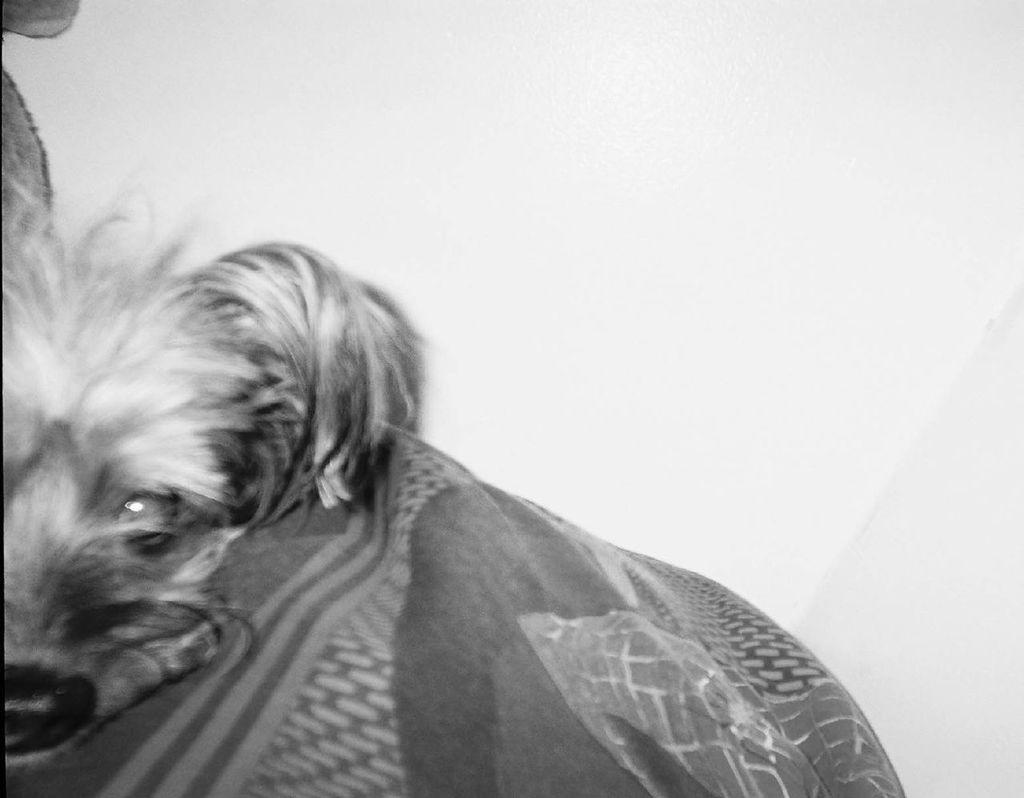What animal is present in the image? There is a dog in the picture. How is the dog positioned or dressed in the image? The dog is wrapped in a cloth. What color is the background of the image? The background of the image is white. Can you see any snakes slithering in the harbor in the image? There is no harbor or snake present in the image; it features a dog wrapped in a cloth with a white background. 